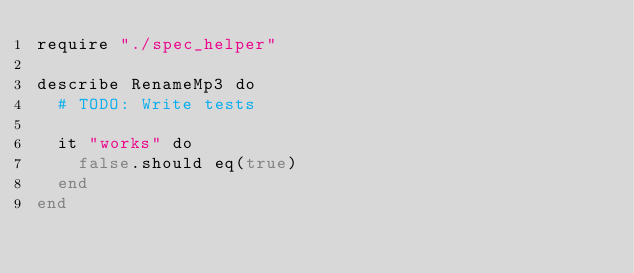Convert code to text. <code><loc_0><loc_0><loc_500><loc_500><_Crystal_>require "./spec_helper"

describe RenameMp3 do
  # TODO: Write tests

  it "works" do
    false.should eq(true)
  end
end
</code> 